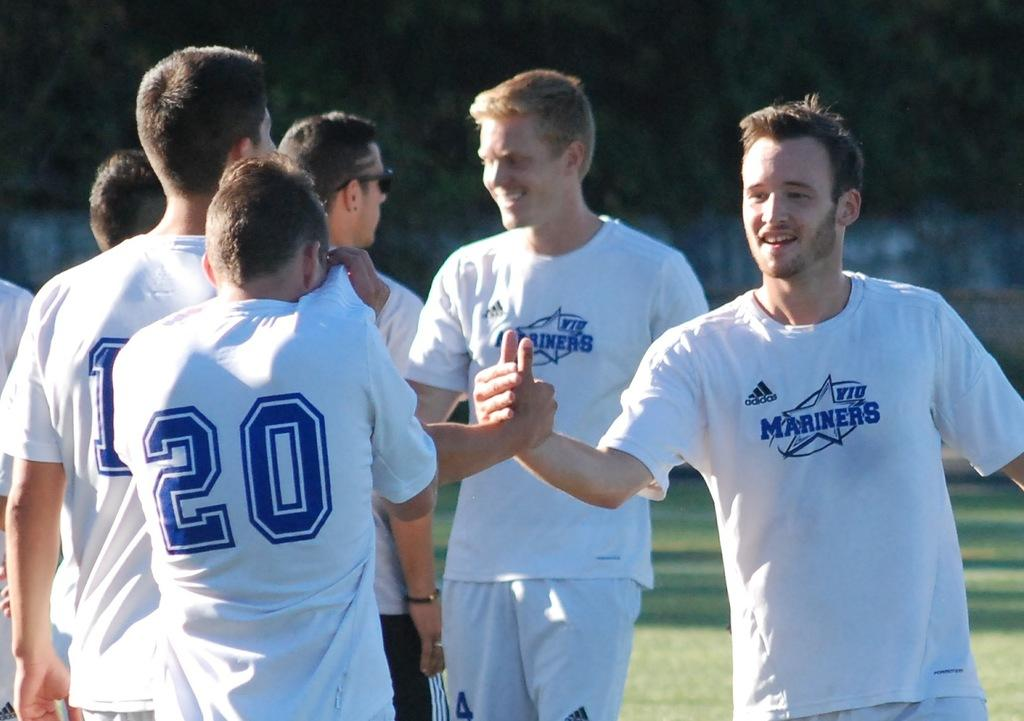<image>
Relay a brief, clear account of the picture shown. a person that is wearing a Mariners shirt on a field 